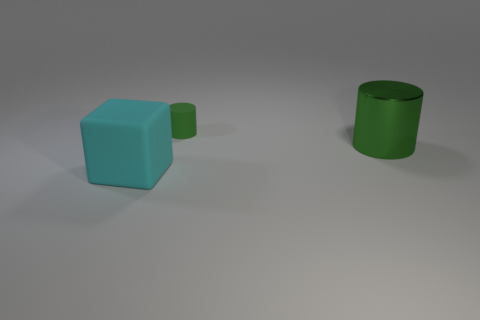How would you compare the sizes of the cyan block and the green cylinders? The cyan block appears to be significantly larger than both green cylinders. While the larger green cylinder is taller than the block, its diameter is much smaller, indicating that overall, the cyan block has a greater volume. Could you estimate the ratio of their sizes? While an exact ratio is difficult to determine without specific measurements, visually, the cyan block's dimensions might be roughly three to four times larger in height and width than the small green cylinder, and approximately equal in height but wider than the large green cylinder. 